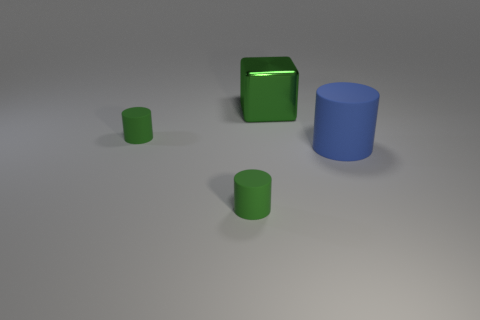Are there any other things that have the same material as the blue cylinder?
Offer a very short reply. Yes. Are there more large cyan rubber objects than matte cylinders?
Your answer should be compact. No. What is the shape of the small green rubber object in front of the tiny rubber cylinder that is to the left of the green cylinder that is in front of the large matte object?
Offer a terse response. Cylinder. Is the big object that is to the right of the metal thing made of the same material as the small green object behind the big rubber object?
Your response must be concise. Yes. Are there any other things that have the same color as the large cylinder?
Your answer should be compact. No. What number of large metallic cubes are there?
Your answer should be very brief. 1. The green cylinder behind the matte thing that is on the right side of the green block is made of what material?
Offer a very short reply. Rubber. What color is the small cylinder that is behind the object in front of the big object that is right of the green metal object?
Offer a terse response. Green. Is the color of the block the same as the big rubber object?
Offer a very short reply. No. How many other green cubes have the same size as the metallic block?
Ensure brevity in your answer.  0. 